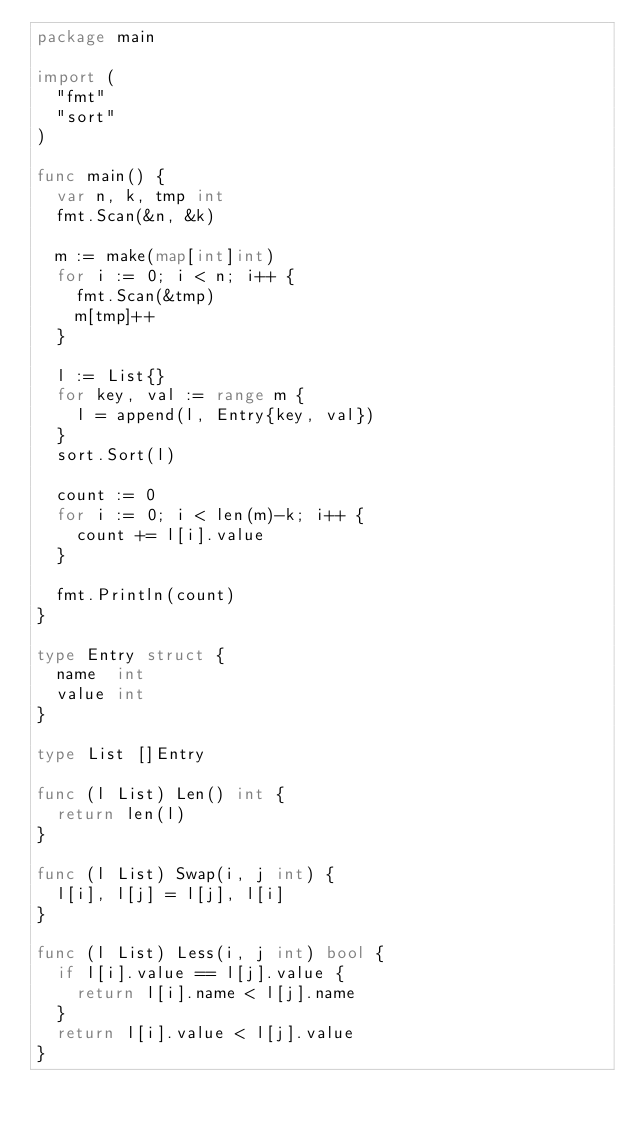Convert code to text. <code><loc_0><loc_0><loc_500><loc_500><_Go_>package main

import (
	"fmt"
	"sort"
)

func main() {
	var n, k, tmp int
	fmt.Scan(&n, &k)

	m := make(map[int]int)
	for i := 0; i < n; i++ {
		fmt.Scan(&tmp)
		m[tmp]++
	}

	l := List{}
	for key, val := range m {
		l = append(l, Entry{key, val})
	}
	sort.Sort(l)

	count := 0
	for i := 0; i < len(m)-k; i++ {
		count += l[i].value
	}

	fmt.Println(count)
}

type Entry struct {
	name  int
	value int
}

type List []Entry

func (l List) Len() int {
	return len(l)
}

func (l List) Swap(i, j int) {
	l[i], l[j] = l[j], l[i]
}

func (l List) Less(i, j int) bool {
	if l[i].value == l[j].value {
		return l[i].name < l[j].name
	}
	return l[i].value < l[j].value
}
</code> 